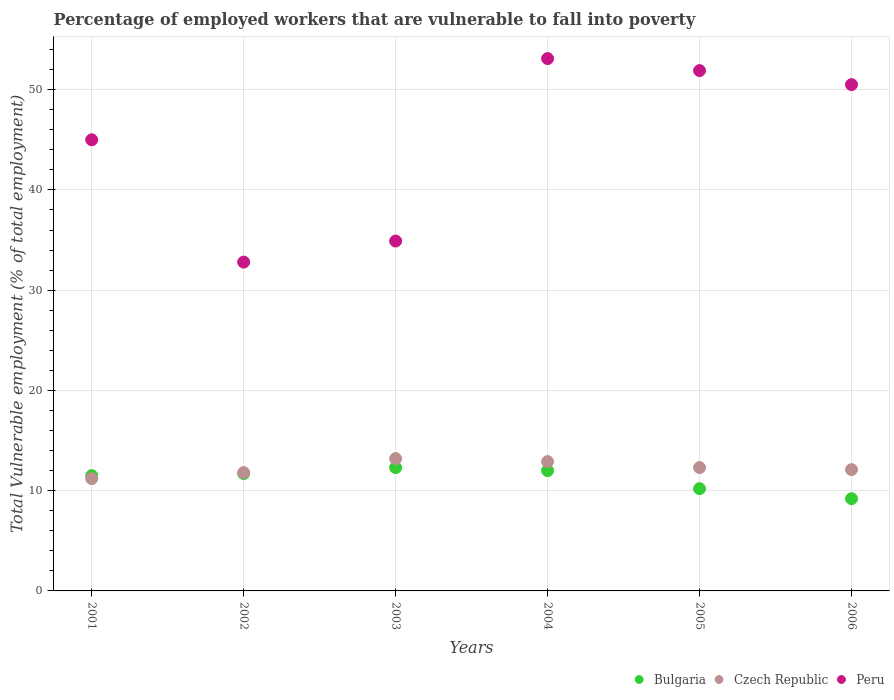How many different coloured dotlines are there?
Make the answer very short. 3. Is the number of dotlines equal to the number of legend labels?
Give a very brief answer. Yes. What is the percentage of employed workers who are vulnerable to fall into poverty in Bulgaria in 2002?
Your response must be concise. 11.7. Across all years, what is the maximum percentage of employed workers who are vulnerable to fall into poverty in Czech Republic?
Offer a terse response. 13.2. Across all years, what is the minimum percentage of employed workers who are vulnerable to fall into poverty in Bulgaria?
Your answer should be very brief. 9.2. In which year was the percentage of employed workers who are vulnerable to fall into poverty in Peru maximum?
Provide a succinct answer. 2004. In which year was the percentage of employed workers who are vulnerable to fall into poverty in Bulgaria minimum?
Offer a terse response. 2006. What is the total percentage of employed workers who are vulnerable to fall into poverty in Czech Republic in the graph?
Provide a succinct answer. 73.5. What is the difference between the percentage of employed workers who are vulnerable to fall into poverty in Czech Republic in 2003 and that in 2005?
Make the answer very short. 0.9. What is the difference between the percentage of employed workers who are vulnerable to fall into poverty in Bulgaria in 2004 and the percentage of employed workers who are vulnerable to fall into poverty in Peru in 2001?
Your answer should be very brief. -33. What is the average percentage of employed workers who are vulnerable to fall into poverty in Peru per year?
Provide a short and direct response. 44.7. In the year 2006, what is the difference between the percentage of employed workers who are vulnerable to fall into poverty in Bulgaria and percentage of employed workers who are vulnerable to fall into poverty in Peru?
Your answer should be compact. -41.3. What is the ratio of the percentage of employed workers who are vulnerable to fall into poverty in Peru in 2001 to that in 2003?
Provide a short and direct response. 1.29. Is the percentage of employed workers who are vulnerable to fall into poverty in Bulgaria in 2002 less than that in 2005?
Your answer should be compact. No. What is the difference between the highest and the second highest percentage of employed workers who are vulnerable to fall into poverty in Peru?
Make the answer very short. 1.2. What is the difference between the highest and the lowest percentage of employed workers who are vulnerable to fall into poverty in Peru?
Keep it short and to the point. 20.3. In how many years, is the percentage of employed workers who are vulnerable to fall into poverty in Peru greater than the average percentage of employed workers who are vulnerable to fall into poverty in Peru taken over all years?
Your response must be concise. 4. Is the sum of the percentage of employed workers who are vulnerable to fall into poverty in Bulgaria in 2003 and 2006 greater than the maximum percentage of employed workers who are vulnerable to fall into poverty in Peru across all years?
Keep it short and to the point. No. Is it the case that in every year, the sum of the percentage of employed workers who are vulnerable to fall into poverty in Bulgaria and percentage of employed workers who are vulnerable to fall into poverty in Czech Republic  is greater than the percentage of employed workers who are vulnerable to fall into poverty in Peru?
Ensure brevity in your answer.  No. Is the percentage of employed workers who are vulnerable to fall into poverty in Peru strictly less than the percentage of employed workers who are vulnerable to fall into poverty in Bulgaria over the years?
Give a very brief answer. No. How many dotlines are there?
Your response must be concise. 3. How many years are there in the graph?
Give a very brief answer. 6. Are the values on the major ticks of Y-axis written in scientific E-notation?
Your answer should be very brief. No. Does the graph contain grids?
Offer a very short reply. Yes. Where does the legend appear in the graph?
Your response must be concise. Bottom right. How are the legend labels stacked?
Keep it short and to the point. Horizontal. What is the title of the graph?
Provide a short and direct response. Percentage of employed workers that are vulnerable to fall into poverty. Does "East Asia (developing only)" appear as one of the legend labels in the graph?
Keep it short and to the point. No. What is the label or title of the X-axis?
Offer a very short reply. Years. What is the label or title of the Y-axis?
Your response must be concise. Total Vulnerable employment (% of total employment). What is the Total Vulnerable employment (% of total employment) in Bulgaria in 2001?
Your answer should be compact. 11.5. What is the Total Vulnerable employment (% of total employment) of Czech Republic in 2001?
Offer a very short reply. 11.2. What is the Total Vulnerable employment (% of total employment) in Bulgaria in 2002?
Ensure brevity in your answer.  11.7. What is the Total Vulnerable employment (% of total employment) of Czech Republic in 2002?
Offer a very short reply. 11.8. What is the Total Vulnerable employment (% of total employment) in Peru in 2002?
Your answer should be compact. 32.8. What is the Total Vulnerable employment (% of total employment) of Bulgaria in 2003?
Offer a terse response. 12.3. What is the Total Vulnerable employment (% of total employment) of Czech Republic in 2003?
Offer a very short reply. 13.2. What is the Total Vulnerable employment (% of total employment) in Peru in 2003?
Your answer should be very brief. 34.9. What is the Total Vulnerable employment (% of total employment) of Bulgaria in 2004?
Give a very brief answer. 12. What is the Total Vulnerable employment (% of total employment) of Czech Republic in 2004?
Offer a very short reply. 12.9. What is the Total Vulnerable employment (% of total employment) of Peru in 2004?
Offer a very short reply. 53.1. What is the Total Vulnerable employment (% of total employment) in Bulgaria in 2005?
Ensure brevity in your answer.  10.2. What is the Total Vulnerable employment (% of total employment) of Czech Republic in 2005?
Provide a succinct answer. 12.3. What is the Total Vulnerable employment (% of total employment) of Peru in 2005?
Offer a terse response. 51.9. What is the Total Vulnerable employment (% of total employment) of Bulgaria in 2006?
Offer a very short reply. 9.2. What is the Total Vulnerable employment (% of total employment) in Czech Republic in 2006?
Your response must be concise. 12.1. What is the Total Vulnerable employment (% of total employment) of Peru in 2006?
Offer a very short reply. 50.5. Across all years, what is the maximum Total Vulnerable employment (% of total employment) of Bulgaria?
Your response must be concise. 12.3. Across all years, what is the maximum Total Vulnerable employment (% of total employment) in Czech Republic?
Ensure brevity in your answer.  13.2. Across all years, what is the maximum Total Vulnerable employment (% of total employment) in Peru?
Provide a short and direct response. 53.1. Across all years, what is the minimum Total Vulnerable employment (% of total employment) in Bulgaria?
Keep it short and to the point. 9.2. Across all years, what is the minimum Total Vulnerable employment (% of total employment) in Czech Republic?
Keep it short and to the point. 11.2. Across all years, what is the minimum Total Vulnerable employment (% of total employment) in Peru?
Offer a very short reply. 32.8. What is the total Total Vulnerable employment (% of total employment) in Bulgaria in the graph?
Give a very brief answer. 66.9. What is the total Total Vulnerable employment (% of total employment) in Czech Republic in the graph?
Offer a terse response. 73.5. What is the total Total Vulnerable employment (% of total employment) of Peru in the graph?
Your answer should be compact. 268.2. What is the difference between the Total Vulnerable employment (% of total employment) of Bulgaria in 2001 and that in 2002?
Provide a short and direct response. -0.2. What is the difference between the Total Vulnerable employment (% of total employment) of Peru in 2001 and that in 2002?
Provide a succinct answer. 12.2. What is the difference between the Total Vulnerable employment (% of total employment) of Czech Republic in 2001 and that in 2003?
Provide a short and direct response. -2. What is the difference between the Total Vulnerable employment (% of total employment) in Peru in 2001 and that in 2004?
Provide a short and direct response. -8.1. What is the difference between the Total Vulnerable employment (% of total employment) in Bulgaria in 2001 and that in 2005?
Offer a terse response. 1.3. What is the difference between the Total Vulnerable employment (% of total employment) in Czech Republic in 2001 and that in 2005?
Offer a very short reply. -1.1. What is the difference between the Total Vulnerable employment (% of total employment) of Peru in 2001 and that in 2006?
Provide a succinct answer. -5.5. What is the difference between the Total Vulnerable employment (% of total employment) in Bulgaria in 2002 and that in 2003?
Make the answer very short. -0.6. What is the difference between the Total Vulnerable employment (% of total employment) in Czech Republic in 2002 and that in 2003?
Your answer should be compact. -1.4. What is the difference between the Total Vulnerable employment (% of total employment) of Peru in 2002 and that in 2003?
Provide a short and direct response. -2.1. What is the difference between the Total Vulnerable employment (% of total employment) of Bulgaria in 2002 and that in 2004?
Your answer should be very brief. -0.3. What is the difference between the Total Vulnerable employment (% of total employment) in Peru in 2002 and that in 2004?
Make the answer very short. -20.3. What is the difference between the Total Vulnerable employment (% of total employment) of Bulgaria in 2002 and that in 2005?
Make the answer very short. 1.5. What is the difference between the Total Vulnerable employment (% of total employment) of Czech Republic in 2002 and that in 2005?
Your answer should be very brief. -0.5. What is the difference between the Total Vulnerable employment (% of total employment) in Peru in 2002 and that in 2005?
Keep it short and to the point. -19.1. What is the difference between the Total Vulnerable employment (% of total employment) of Bulgaria in 2002 and that in 2006?
Provide a short and direct response. 2.5. What is the difference between the Total Vulnerable employment (% of total employment) in Peru in 2002 and that in 2006?
Offer a very short reply. -17.7. What is the difference between the Total Vulnerable employment (% of total employment) of Peru in 2003 and that in 2004?
Your answer should be very brief. -18.2. What is the difference between the Total Vulnerable employment (% of total employment) of Bulgaria in 2003 and that in 2005?
Provide a short and direct response. 2.1. What is the difference between the Total Vulnerable employment (% of total employment) of Bulgaria in 2003 and that in 2006?
Give a very brief answer. 3.1. What is the difference between the Total Vulnerable employment (% of total employment) of Peru in 2003 and that in 2006?
Keep it short and to the point. -15.6. What is the difference between the Total Vulnerable employment (% of total employment) in Peru in 2004 and that in 2005?
Make the answer very short. 1.2. What is the difference between the Total Vulnerable employment (% of total employment) in Bulgaria in 2004 and that in 2006?
Make the answer very short. 2.8. What is the difference between the Total Vulnerable employment (% of total employment) in Czech Republic in 2004 and that in 2006?
Offer a very short reply. 0.8. What is the difference between the Total Vulnerable employment (% of total employment) of Bulgaria in 2005 and that in 2006?
Make the answer very short. 1. What is the difference between the Total Vulnerable employment (% of total employment) in Bulgaria in 2001 and the Total Vulnerable employment (% of total employment) in Peru in 2002?
Offer a terse response. -21.3. What is the difference between the Total Vulnerable employment (% of total employment) in Czech Republic in 2001 and the Total Vulnerable employment (% of total employment) in Peru in 2002?
Offer a very short reply. -21.6. What is the difference between the Total Vulnerable employment (% of total employment) of Bulgaria in 2001 and the Total Vulnerable employment (% of total employment) of Peru in 2003?
Offer a very short reply. -23.4. What is the difference between the Total Vulnerable employment (% of total employment) of Czech Republic in 2001 and the Total Vulnerable employment (% of total employment) of Peru in 2003?
Offer a terse response. -23.7. What is the difference between the Total Vulnerable employment (% of total employment) in Bulgaria in 2001 and the Total Vulnerable employment (% of total employment) in Peru in 2004?
Provide a short and direct response. -41.6. What is the difference between the Total Vulnerable employment (% of total employment) in Czech Republic in 2001 and the Total Vulnerable employment (% of total employment) in Peru in 2004?
Your answer should be very brief. -41.9. What is the difference between the Total Vulnerable employment (% of total employment) in Bulgaria in 2001 and the Total Vulnerable employment (% of total employment) in Czech Republic in 2005?
Offer a very short reply. -0.8. What is the difference between the Total Vulnerable employment (% of total employment) in Bulgaria in 2001 and the Total Vulnerable employment (% of total employment) in Peru in 2005?
Make the answer very short. -40.4. What is the difference between the Total Vulnerable employment (% of total employment) of Czech Republic in 2001 and the Total Vulnerable employment (% of total employment) of Peru in 2005?
Make the answer very short. -40.7. What is the difference between the Total Vulnerable employment (% of total employment) in Bulgaria in 2001 and the Total Vulnerable employment (% of total employment) in Czech Republic in 2006?
Offer a very short reply. -0.6. What is the difference between the Total Vulnerable employment (% of total employment) in Bulgaria in 2001 and the Total Vulnerable employment (% of total employment) in Peru in 2006?
Provide a short and direct response. -39. What is the difference between the Total Vulnerable employment (% of total employment) in Czech Republic in 2001 and the Total Vulnerable employment (% of total employment) in Peru in 2006?
Provide a short and direct response. -39.3. What is the difference between the Total Vulnerable employment (% of total employment) in Bulgaria in 2002 and the Total Vulnerable employment (% of total employment) in Czech Republic in 2003?
Keep it short and to the point. -1.5. What is the difference between the Total Vulnerable employment (% of total employment) in Bulgaria in 2002 and the Total Vulnerable employment (% of total employment) in Peru in 2003?
Ensure brevity in your answer.  -23.2. What is the difference between the Total Vulnerable employment (% of total employment) in Czech Republic in 2002 and the Total Vulnerable employment (% of total employment) in Peru in 2003?
Your answer should be compact. -23.1. What is the difference between the Total Vulnerable employment (% of total employment) in Bulgaria in 2002 and the Total Vulnerable employment (% of total employment) in Czech Republic in 2004?
Offer a very short reply. -1.2. What is the difference between the Total Vulnerable employment (% of total employment) in Bulgaria in 2002 and the Total Vulnerable employment (% of total employment) in Peru in 2004?
Ensure brevity in your answer.  -41.4. What is the difference between the Total Vulnerable employment (% of total employment) in Czech Republic in 2002 and the Total Vulnerable employment (% of total employment) in Peru in 2004?
Keep it short and to the point. -41.3. What is the difference between the Total Vulnerable employment (% of total employment) in Bulgaria in 2002 and the Total Vulnerable employment (% of total employment) in Czech Republic in 2005?
Offer a terse response. -0.6. What is the difference between the Total Vulnerable employment (% of total employment) of Bulgaria in 2002 and the Total Vulnerable employment (% of total employment) of Peru in 2005?
Make the answer very short. -40.2. What is the difference between the Total Vulnerable employment (% of total employment) in Czech Republic in 2002 and the Total Vulnerable employment (% of total employment) in Peru in 2005?
Provide a succinct answer. -40.1. What is the difference between the Total Vulnerable employment (% of total employment) of Bulgaria in 2002 and the Total Vulnerable employment (% of total employment) of Peru in 2006?
Your response must be concise. -38.8. What is the difference between the Total Vulnerable employment (% of total employment) in Czech Republic in 2002 and the Total Vulnerable employment (% of total employment) in Peru in 2006?
Provide a succinct answer. -38.7. What is the difference between the Total Vulnerable employment (% of total employment) in Bulgaria in 2003 and the Total Vulnerable employment (% of total employment) in Czech Republic in 2004?
Provide a succinct answer. -0.6. What is the difference between the Total Vulnerable employment (% of total employment) in Bulgaria in 2003 and the Total Vulnerable employment (% of total employment) in Peru in 2004?
Keep it short and to the point. -40.8. What is the difference between the Total Vulnerable employment (% of total employment) of Czech Republic in 2003 and the Total Vulnerable employment (% of total employment) of Peru in 2004?
Offer a very short reply. -39.9. What is the difference between the Total Vulnerable employment (% of total employment) of Bulgaria in 2003 and the Total Vulnerable employment (% of total employment) of Czech Republic in 2005?
Make the answer very short. 0. What is the difference between the Total Vulnerable employment (% of total employment) in Bulgaria in 2003 and the Total Vulnerable employment (% of total employment) in Peru in 2005?
Give a very brief answer. -39.6. What is the difference between the Total Vulnerable employment (% of total employment) of Czech Republic in 2003 and the Total Vulnerable employment (% of total employment) of Peru in 2005?
Make the answer very short. -38.7. What is the difference between the Total Vulnerable employment (% of total employment) of Bulgaria in 2003 and the Total Vulnerable employment (% of total employment) of Czech Republic in 2006?
Your answer should be compact. 0.2. What is the difference between the Total Vulnerable employment (% of total employment) in Bulgaria in 2003 and the Total Vulnerable employment (% of total employment) in Peru in 2006?
Offer a terse response. -38.2. What is the difference between the Total Vulnerable employment (% of total employment) in Czech Republic in 2003 and the Total Vulnerable employment (% of total employment) in Peru in 2006?
Give a very brief answer. -37.3. What is the difference between the Total Vulnerable employment (% of total employment) of Bulgaria in 2004 and the Total Vulnerable employment (% of total employment) of Czech Republic in 2005?
Make the answer very short. -0.3. What is the difference between the Total Vulnerable employment (% of total employment) in Bulgaria in 2004 and the Total Vulnerable employment (% of total employment) in Peru in 2005?
Provide a succinct answer. -39.9. What is the difference between the Total Vulnerable employment (% of total employment) in Czech Republic in 2004 and the Total Vulnerable employment (% of total employment) in Peru in 2005?
Your response must be concise. -39. What is the difference between the Total Vulnerable employment (% of total employment) of Bulgaria in 2004 and the Total Vulnerable employment (% of total employment) of Peru in 2006?
Provide a succinct answer. -38.5. What is the difference between the Total Vulnerable employment (% of total employment) in Czech Republic in 2004 and the Total Vulnerable employment (% of total employment) in Peru in 2006?
Your answer should be compact. -37.6. What is the difference between the Total Vulnerable employment (% of total employment) of Bulgaria in 2005 and the Total Vulnerable employment (% of total employment) of Peru in 2006?
Provide a succinct answer. -40.3. What is the difference between the Total Vulnerable employment (% of total employment) of Czech Republic in 2005 and the Total Vulnerable employment (% of total employment) of Peru in 2006?
Keep it short and to the point. -38.2. What is the average Total Vulnerable employment (% of total employment) in Bulgaria per year?
Offer a terse response. 11.15. What is the average Total Vulnerable employment (% of total employment) of Czech Republic per year?
Make the answer very short. 12.25. What is the average Total Vulnerable employment (% of total employment) in Peru per year?
Offer a terse response. 44.7. In the year 2001, what is the difference between the Total Vulnerable employment (% of total employment) of Bulgaria and Total Vulnerable employment (% of total employment) of Peru?
Provide a short and direct response. -33.5. In the year 2001, what is the difference between the Total Vulnerable employment (% of total employment) in Czech Republic and Total Vulnerable employment (% of total employment) in Peru?
Give a very brief answer. -33.8. In the year 2002, what is the difference between the Total Vulnerable employment (% of total employment) in Bulgaria and Total Vulnerable employment (% of total employment) in Czech Republic?
Your response must be concise. -0.1. In the year 2002, what is the difference between the Total Vulnerable employment (% of total employment) in Bulgaria and Total Vulnerable employment (% of total employment) in Peru?
Ensure brevity in your answer.  -21.1. In the year 2003, what is the difference between the Total Vulnerable employment (% of total employment) of Bulgaria and Total Vulnerable employment (% of total employment) of Czech Republic?
Offer a very short reply. -0.9. In the year 2003, what is the difference between the Total Vulnerable employment (% of total employment) of Bulgaria and Total Vulnerable employment (% of total employment) of Peru?
Your answer should be compact. -22.6. In the year 2003, what is the difference between the Total Vulnerable employment (% of total employment) in Czech Republic and Total Vulnerable employment (% of total employment) in Peru?
Provide a succinct answer. -21.7. In the year 2004, what is the difference between the Total Vulnerable employment (% of total employment) in Bulgaria and Total Vulnerable employment (% of total employment) in Peru?
Your answer should be very brief. -41.1. In the year 2004, what is the difference between the Total Vulnerable employment (% of total employment) in Czech Republic and Total Vulnerable employment (% of total employment) in Peru?
Your answer should be compact. -40.2. In the year 2005, what is the difference between the Total Vulnerable employment (% of total employment) of Bulgaria and Total Vulnerable employment (% of total employment) of Peru?
Give a very brief answer. -41.7. In the year 2005, what is the difference between the Total Vulnerable employment (% of total employment) in Czech Republic and Total Vulnerable employment (% of total employment) in Peru?
Keep it short and to the point. -39.6. In the year 2006, what is the difference between the Total Vulnerable employment (% of total employment) in Bulgaria and Total Vulnerable employment (% of total employment) in Peru?
Your response must be concise. -41.3. In the year 2006, what is the difference between the Total Vulnerable employment (% of total employment) of Czech Republic and Total Vulnerable employment (% of total employment) of Peru?
Give a very brief answer. -38.4. What is the ratio of the Total Vulnerable employment (% of total employment) of Bulgaria in 2001 to that in 2002?
Give a very brief answer. 0.98. What is the ratio of the Total Vulnerable employment (% of total employment) of Czech Republic in 2001 to that in 2002?
Your answer should be compact. 0.95. What is the ratio of the Total Vulnerable employment (% of total employment) in Peru in 2001 to that in 2002?
Provide a succinct answer. 1.37. What is the ratio of the Total Vulnerable employment (% of total employment) of Bulgaria in 2001 to that in 2003?
Provide a short and direct response. 0.94. What is the ratio of the Total Vulnerable employment (% of total employment) of Czech Republic in 2001 to that in 2003?
Offer a very short reply. 0.85. What is the ratio of the Total Vulnerable employment (% of total employment) in Peru in 2001 to that in 2003?
Keep it short and to the point. 1.29. What is the ratio of the Total Vulnerable employment (% of total employment) in Czech Republic in 2001 to that in 2004?
Your response must be concise. 0.87. What is the ratio of the Total Vulnerable employment (% of total employment) in Peru in 2001 to that in 2004?
Provide a succinct answer. 0.85. What is the ratio of the Total Vulnerable employment (% of total employment) in Bulgaria in 2001 to that in 2005?
Ensure brevity in your answer.  1.13. What is the ratio of the Total Vulnerable employment (% of total employment) in Czech Republic in 2001 to that in 2005?
Make the answer very short. 0.91. What is the ratio of the Total Vulnerable employment (% of total employment) in Peru in 2001 to that in 2005?
Keep it short and to the point. 0.87. What is the ratio of the Total Vulnerable employment (% of total employment) of Czech Republic in 2001 to that in 2006?
Provide a short and direct response. 0.93. What is the ratio of the Total Vulnerable employment (% of total employment) in Peru in 2001 to that in 2006?
Offer a very short reply. 0.89. What is the ratio of the Total Vulnerable employment (% of total employment) in Bulgaria in 2002 to that in 2003?
Give a very brief answer. 0.95. What is the ratio of the Total Vulnerable employment (% of total employment) in Czech Republic in 2002 to that in 2003?
Provide a short and direct response. 0.89. What is the ratio of the Total Vulnerable employment (% of total employment) of Peru in 2002 to that in 2003?
Your answer should be very brief. 0.94. What is the ratio of the Total Vulnerable employment (% of total employment) of Bulgaria in 2002 to that in 2004?
Offer a terse response. 0.97. What is the ratio of the Total Vulnerable employment (% of total employment) in Czech Republic in 2002 to that in 2004?
Provide a short and direct response. 0.91. What is the ratio of the Total Vulnerable employment (% of total employment) of Peru in 2002 to that in 2004?
Your response must be concise. 0.62. What is the ratio of the Total Vulnerable employment (% of total employment) of Bulgaria in 2002 to that in 2005?
Give a very brief answer. 1.15. What is the ratio of the Total Vulnerable employment (% of total employment) of Czech Republic in 2002 to that in 2005?
Ensure brevity in your answer.  0.96. What is the ratio of the Total Vulnerable employment (% of total employment) of Peru in 2002 to that in 2005?
Offer a terse response. 0.63. What is the ratio of the Total Vulnerable employment (% of total employment) in Bulgaria in 2002 to that in 2006?
Your response must be concise. 1.27. What is the ratio of the Total Vulnerable employment (% of total employment) in Czech Republic in 2002 to that in 2006?
Offer a very short reply. 0.98. What is the ratio of the Total Vulnerable employment (% of total employment) in Peru in 2002 to that in 2006?
Offer a very short reply. 0.65. What is the ratio of the Total Vulnerable employment (% of total employment) of Bulgaria in 2003 to that in 2004?
Give a very brief answer. 1.02. What is the ratio of the Total Vulnerable employment (% of total employment) in Czech Republic in 2003 to that in 2004?
Make the answer very short. 1.02. What is the ratio of the Total Vulnerable employment (% of total employment) in Peru in 2003 to that in 2004?
Your answer should be compact. 0.66. What is the ratio of the Total Vulnerable employment (% of total employment) in Bulgaria in 2003 to that in 2005?
Offer a very short reply. 1.21. What is the ratio of the Total Vulnerable employment (% of total employment) in Czech Republic in 2003 to that in 2005?
Your response must be concise. 1.07. What is the ratio of the Total Vulnerable employment (% of total employment) of Peru in 2003 to that in 2005?
Keep it short and to the point. 0.67. What is the ratio of the Total Vulnerable employment (% of total employment) of Bulgaria in 2003 to that in 2006?
Make the answer very short. 1.34. What is the ratio of the Total Vulnerable employment (% of total employment) in Czech Republic in 2003 to that in 2006?
Offer a terse response. 1.09. What is the ratio of the Total Vulnerable employment (% of total employment) in Peru in 2003 to that in 2006?
Provide a succinct answer. 0.69. What is the ratio of the Total Vulnerable employment (% of total employment) in Bulgaria in 2004 to that in 2005?
Provide a short and direct response. 1.18. What is the ratio of the Total Vulnerable employment (% of total employment) in Czech Republic in 2004 to that in 2005?
Make the answer very short. 1.05. What is the ratio of the Total Vulnerable employment (% of total employment) in Peru in 2004 to that in 2005?
Give a very brief answer. 1.02. What is the ratio of the Total Vulnerable employment (% of total employment) in Bulgaria in 2004 to that in 2006?
Your answer should be compact. 1.3. What is the ratio of the Total Vulnerable employment (% of total employment) in Czech Republic in 2004 to that in 2006?
Your answer should be compact. 1.07. What is the ratio of the Total Vulnerable employment (% of total employment) of Peru in 2004 to that in 2006?
Give a very brief answer. 1.05. What is the ratio of the Total Vulnerable employment (% of total employment) of Bulgaria in 2005 to that in 2006?
Provide a short and direct response. 1.11. What is the ratio of the Total Vulnerable employment (% of total employment) of Czech Republic in 2005 to that in 2006?
Your answer should be very brief. 1.02. What is the ratio of the Total Vulnerable employment (% of total employment) in Peru in 2005 to that in 2006?
Give a very brief answer. 1.03. What is the difference between the highest and the second highest Total Vulnerable employment (% of total employment) of Czech Republic?
Provide a succinct answer. 0.3. What is the difference between the highest and the lowest Total Vulnerable employment (% of total employment) in Czech Republic?
Provide a short and direct response. 2. What is the difference between the highest and the lowest Total Vulnerable employment (% of total employment) in Peru?
Your response must be concise. 20.3. 